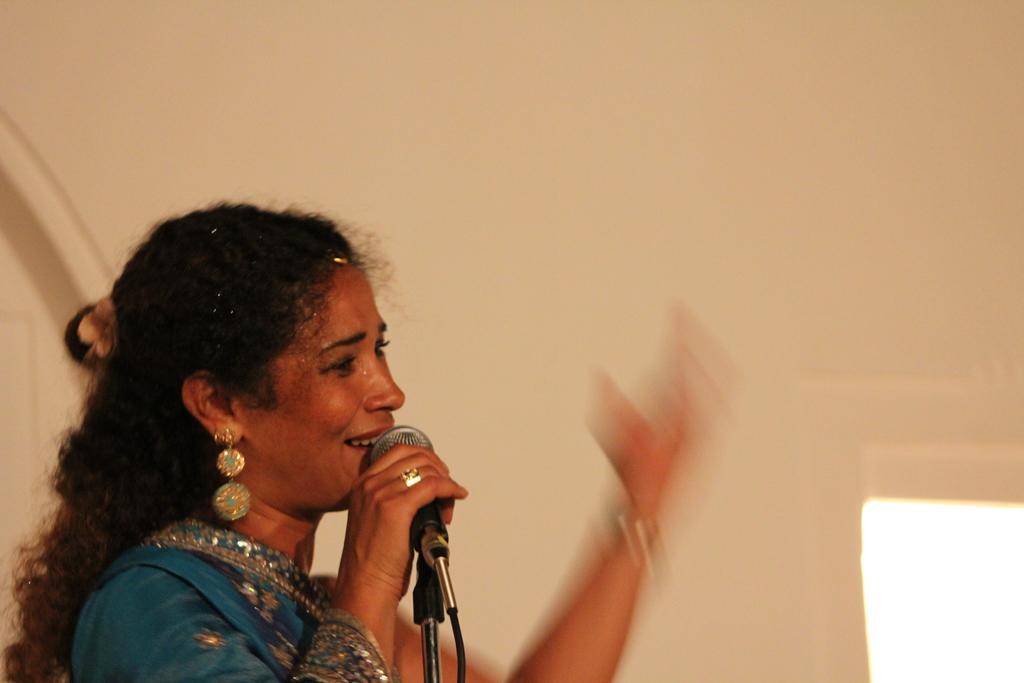Could you give a brief overview of what you see in this image? In this image we can see a woman wearing a dress is holding a microphone in her hand placed on a stand. 